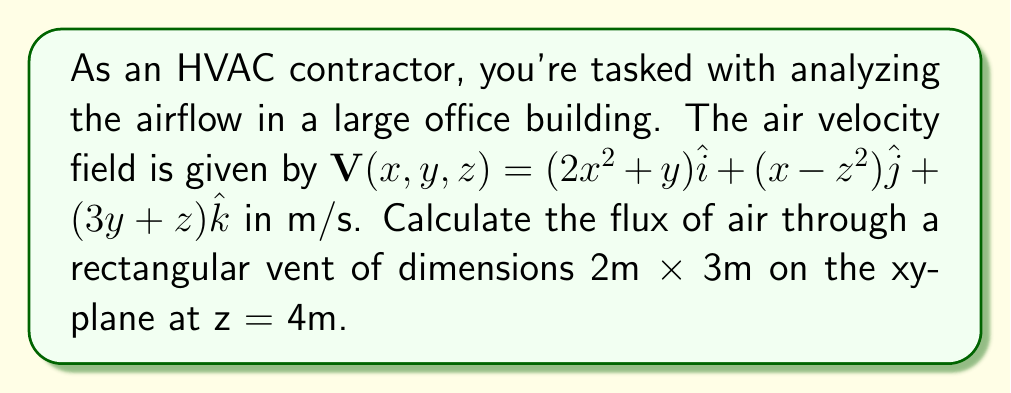Give your solution to this math problem. To solve this problem, we'll use the flux formula from vector calculus:

1) The flux is given by the surface integral: $\Phi = \iint_S \mathbf{V} \cdot d\mathbf{S}$

2) Our surface S is on the xy-plane at z = 4, so $d\mathbf{S} = \hat{k} \, dx \, dy$

3) We need to evaluate $\mathbf{V} \cdot \hat{k}$ at z = 4:
   $\mathbf{V} \cdot \hat{k} = 3y + z = 3y + 4$

4) Our integral becomes:
   $\Phi = \int_0^2 \int_0^3 (3y + 4) \, dy \, dx$

5) Evaluate the inner integral:
   $\Phi = \int_0^2 \left[3\frac{y^2}{2} + 4y\right]_0^3 \, dx$
   $= \int_0^2 \left(\frac{27}{2} + 12\right) \, dx$
   $= \int_0^2 \frac{51}{2} \, dx$

6) Evaluate the outer integral:
   $\Phi = \left[\frac{51}{2}x\right]_0^2 = 51$ m³/s

Therefore, the flux of air through the vent is 51 m³/s.
Answer: 51 m³/s 